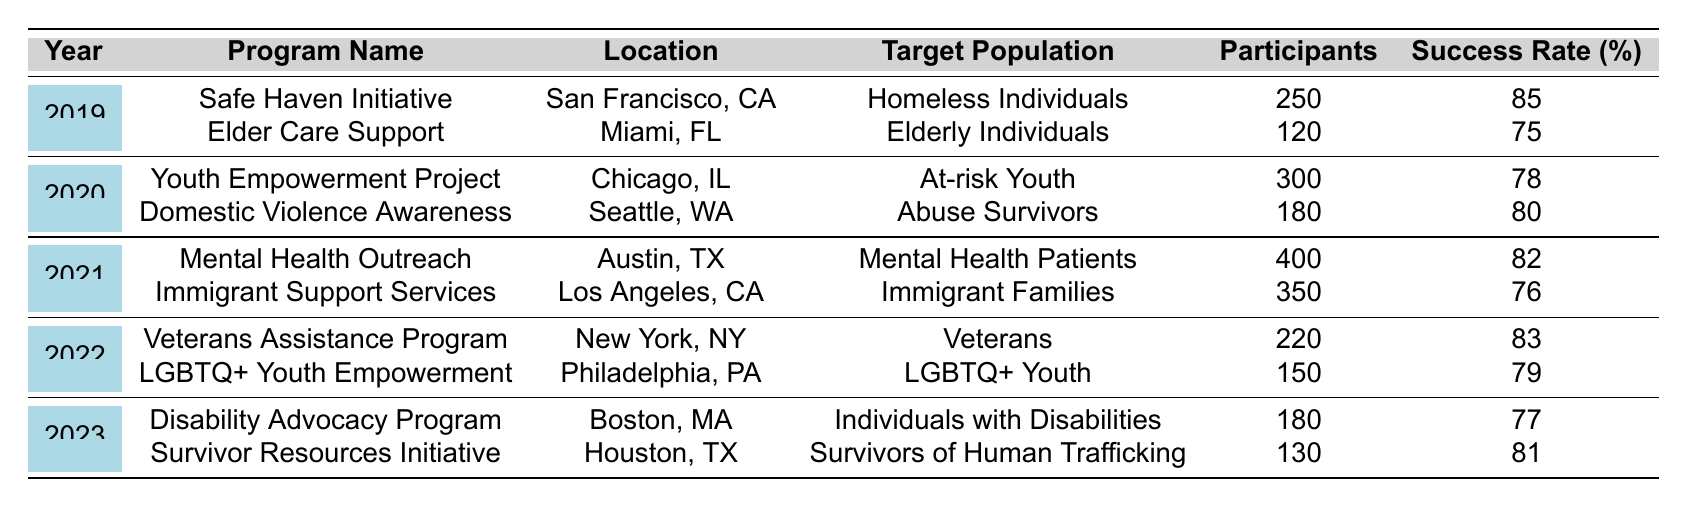What was the program with the highest number of participants in 2021? In 2021, the "Mental Health Outreach" program in Austin, TX had 400 participants, which is more than any other program that year.
Answer: Mental Health Outreach Which target population had a program with the highest success rate in 2019? In 2019, the "Safe Haven Initiative" targeting Homeless Individuals had the highest success rate of 85%.
Answer: Homeless Individuals What is the total funding amount for all programs in the year 2020? Summing the funding amounts for both programs in 2020 gives: $200,000 + $100,000 = $300,000.
Answer: $300,000 Did any program in 2022 focus on Immigrant Families? Referring to the table, in 2022, there was no program listed for Immigrant Families; the relevant program was in 2021.
Answer: No Which location hosted a program for LGBTQ+ Youth? The "LGBTQ+ Youth Empowerment" program was held in Philadelphia, PA in 2022.
Answer: Philadelphia, PA Calculate the average number of participants across all programs from 2019 to 2023. The total number of participants from all years is: 250 + 120 + 300 + 180 + 400 + 350 + 220 + 150 + 180 + 130 = 2080. With 10 programs in total, the average is 2080 / 10 = 208.
Answer: 208 What year had the lowest funding amount for a single program? Examining the table shows that in 2019, the "Elder Care Support" program had the lowest funding amount of $80,000.
Answer: 2019 Which program targeted Survivors of Human Trafficking, and what was its success rate? The "Survivor Resources Initiative" in Houston, TX targeted Survivors of Human Trafficking, and it had a success rate of 81%.
Answer: 81% Identify the year when the program with the least participants occurred. The "Elder Care Support" program had only 120 participants in 2019, making it the program with the least participants.
Answer: 2019 How many programs targeted at-risk populations across all years? Summing the relevant programs gives us 1 for Homeless Individuals, 1 for Abuse Survivors, 1 for At-risk Youth, 1 for Mental Health Patients, 1 for Immigrant Families, 1 for Veterans, 1 for LGBTQ+ Youth, and 1 for Survivors of Human Trafficking, resulting in 8 programs focused on at-risk populations.
Answer: 8 